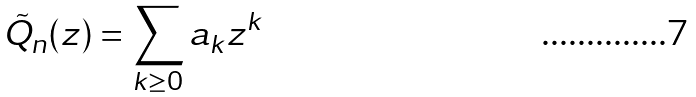<formula> <loc_0><loc_0><loc_500><loc_500>\tilde { Q } _ { n } ( z ) = \sum _ { k \geq 0 } a _ { k } z ^ { k }</formula> 